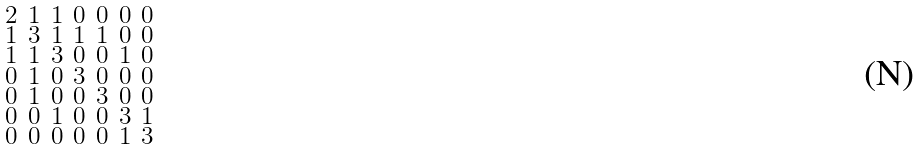<formula> <loc_0><loc_0><loc_500><loc_500>\begin{smallmatrix} 2 & 1 & 1 & 0 & 0 & 0 & 0 \\ 1 & 3 & 1 & 1 & 1 & 0 & 0 \\ 1 & 1 & 3 & 0 & 0 & 1 & 0 \\ 0 & 1 & 0 & 3 & 0 & 0 & 0 \\ 0 & 1 & 0 & 0 & 3 & 0 & 0 \\ 0 & 0 & 1 & 0 & 0 & 3 & 1 \\ 0 & 0 & 0 & 0 & 0 & 1 & 3 \end{smallmatrix}</formula> 